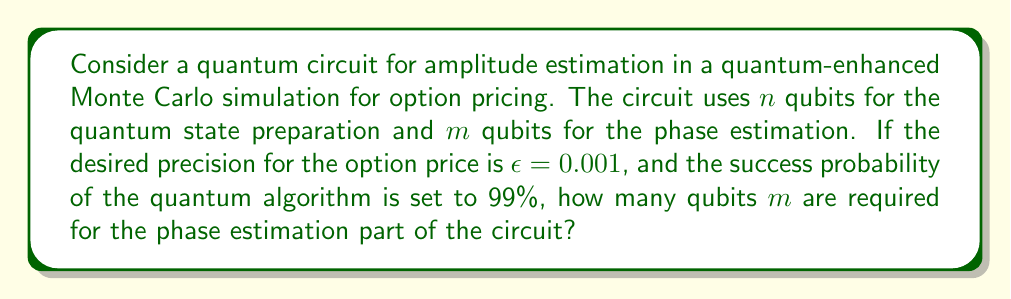Can you solve this math problem? To solve this problem, we need to understand the relationship between the number of qubits used in phase estimation, the desired precision, and the success probability of the quantum algorithm.

1. In amplitude estimation, the precision $\epsilon$ is related to the number of qubits $m$ used in phase estimation by:

   $$\epsilon = \frac{\pi}{2^m}$$

2. We can rearrange this equation to solve for $m$:

   $$m = \log_2\left(\frac{\pi}{\epsilon}\right)$$

3. However, this only gives us the minimum number of qubits needed for the desired precision. To account for the success probability, we need to use the formula:

   $$m = \left\lceil\log_2\left(\frac{\pi}{\epsilon}\right) + \log_2\left(\frac{2}{\delta}\right)\right\rceil$$

   Where $\delta$ is the failure probability (1 - success probability).

4. Given:
   - Precision $\epsilon = 0.001$
   - Success probability = 99%, so failure probability $\delta = 0.01$

5. Let's substitute these values into the equation:

   $$m = \left\lceil\log_2\left(\frac{\pi}{0.001}\right) + \log_2\left(\frac{2}{0.01}\right)\right\rceil$$

6. Simplify:
   $$m = \left\lceil\log_2(3141.59) + \log_2(200)\right\rceil$$

7. Calculate:
   $$m = \left\lceil11.62 + 7.64\right\rceil = \left\lceil19.26\right\rceil = 20$$

Therefore, 20 qubits are required for the phase estimation part of the circuit to achieve the desired precision with 99% success probability.
Answer: 20 qubits 